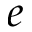Convert formula to latex. <formula><loc_0><loc_0><loc_500><loc_500>e</formula> 